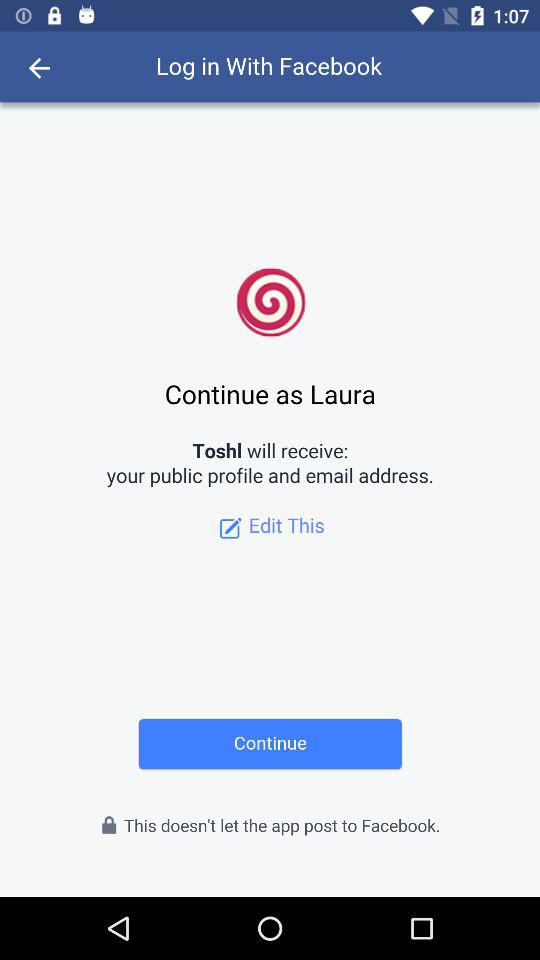What's the application that will receive the public profile and email address? The application that will receive the public profile and email address is "Toshl". 